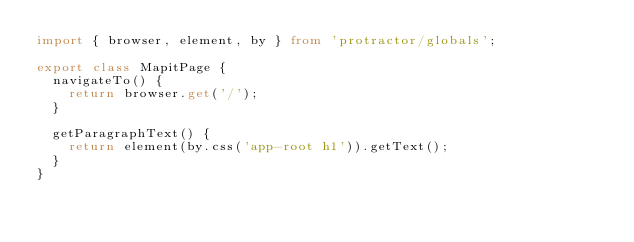Convert code to text. <code><loc_0><loc_0><loc_500><loc_500><_TypeScript_>import { browser, element, by } from 'protractor/globals';

export class MapitPage {
  navigateTo() {
    return browser.get('/');
  }

  getParagraphText() {
    return element(by.css('app-root h1')).getText();
  }
}
</code> 